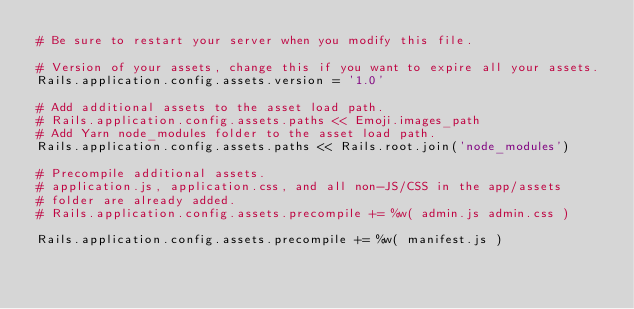<code> <loc_0><loc_0><loc_500><loc_500><_Ruby_># Be sure to restart your server when you modify this file.

# Version of your assets, change this if you want to expire all your assets.
Rails.application.config.assets.version = '1.0'

# Add additional assets to the asset load path.
# Rails.application.config.assets.paths << Emoji.images_path
# Add Yarn node_modules folder to the asset load path.
Rails.application.config.assets.paths << Rails.root.join('node_modules')

# Precompile additional assets.
# application.js, application.css, and all non-JS/CSS in the app/assets
# folder are already added.
# Rails.application.config.assets.precompile += %w( admin.js admin.css )

Rails.application.config.assets.precompile += %w( manifest.js )
</code> 